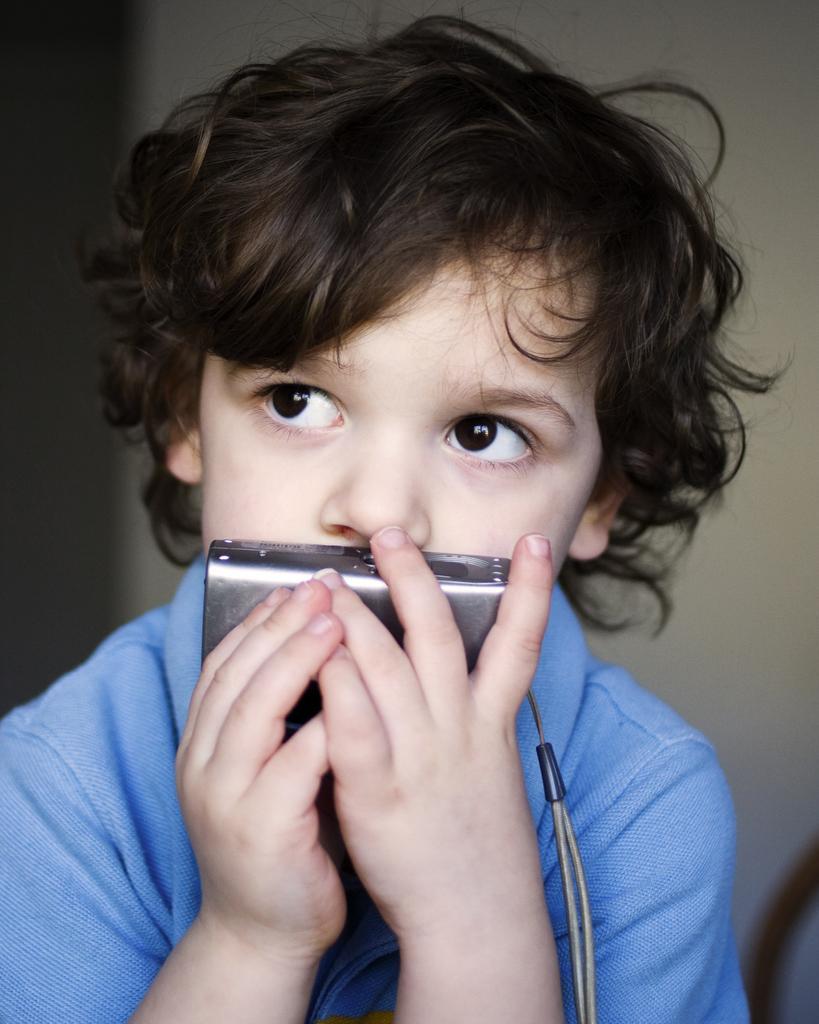Could you give a brief overview of what you see in this image? In this image we can see a boy holding a camera in his hand. 